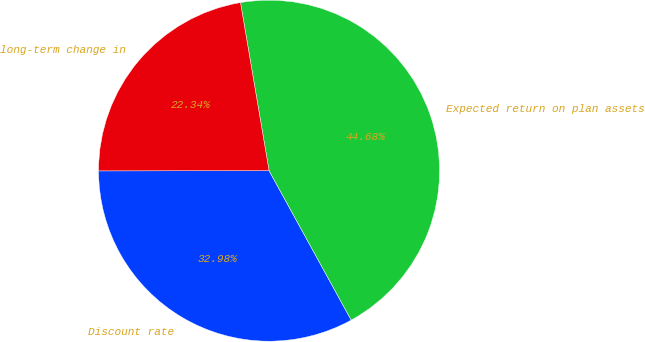<chart> <loc_0><loc_0><loc_500><loc_500><pie_chart><fcel>Discount rate<fcel>Expected return on plan assets<fcel>long-term change in<nl><fcel>32.98%<fcel>44.68%<fcel>22.34%<nl></chart> 